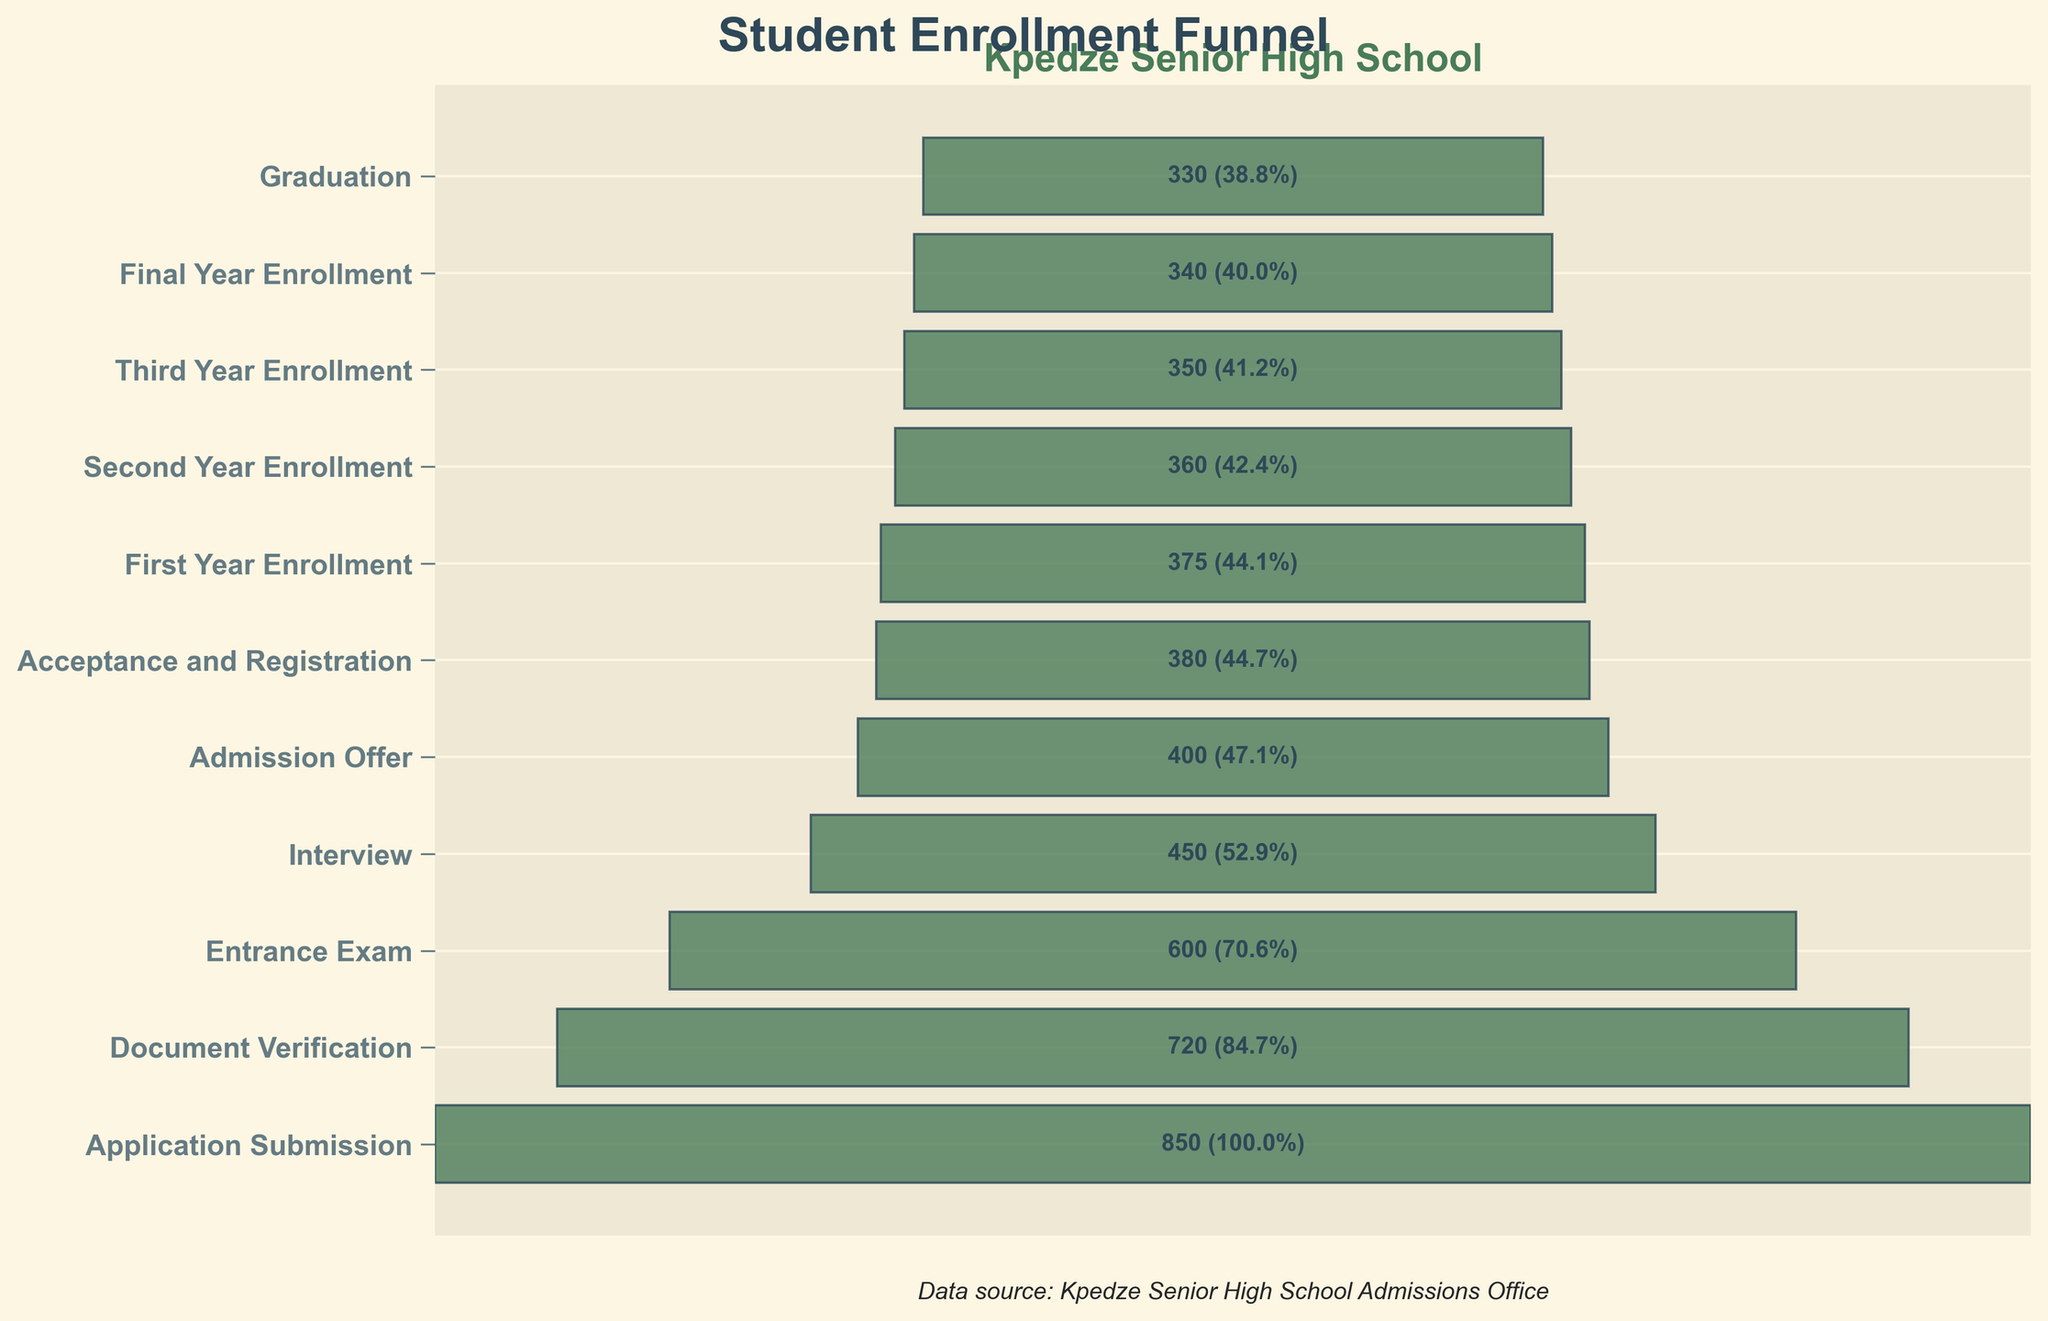What's the highest stage of student enrollment at Kpedze Senior High School? The highest stage in the funnel chart is the first stage at the top, which is 'Application Submission' with a total of 850 students.
Answer: Application Submission What is the title of the figure? The title of the figure is prominently displayed at the top of the chart, with a larger font size, often indicating the subject of the figure. In this chart, the title is 'Student Enrollment Funnel'.
Answer: Student Enrollment Funnel How many students accepted the admission offer and completed registration? To find the number of students at the 'Acceptance and Registration' stage, locate the corresponding stage in the funnel chart and refer to the indicated number of students.
Answer: 380 Which stages have fewer than 500 students? To determine which stages have fewer than 500 students, review the number of students next to each stage in the funnel chart. Any stage with a number below 500 meets this criterion. The stages 'Interview', 'Admission Offer', 'Acceptance and Registration', 'First Year Enrollment', 'Second Year Enrollment', 'Third Year Enrollment', 'Final Year Enrollment', and 'Graduation' all have fewer than 500 students.
Answer: Interview, Admission Offer, Acceptance and Registration, First Year Enrollment, Second Year Enrollment, Third Year Enrollment, Final Year Enrollment, Graduation How many students did not graduate after enrolling in the final year? To find this, subtract the number of students in the 'Graduation' stage from the number in the 'Final Year Enrollment' stage. In this case, it is 340 - 330.
Answer: 10 students How much does the student count drop from the 'Entrance Exam' stage to the 'Interview' stage? To find the drop in the number of students, subtract the number of students in the 'Interview' stage from the number in the 'Entrance Exam' stage. This is 600 - 450.
Answer: 150 students What's the percentage of students who go from 'Interview' to 'Admission Offer'? To find this, divide the number of students in the 'Admission Offer' stage by the number in the 'Interview' stage and multiply by 100. This is (400 / 450) * 100%.
Answer: 88.89% Which stage has the lowest count of students? Identify the stage with the smallest number of students from the funnel chart. The stage 'Graduation' has the lowest figure.
Answer: Graduation Compare the number of students between 'First Year Enrollment' and 'Second Year Enrollment'. Review the student counts for 'First Year Enrollment' and 'Second Year Enrollment' from the chart, then compare the two numbers. 'First Year Enrollment' has 375 students, and 'Second Year Enrollment' has 360.
Answer: First Year Enrollment has more students What is the overall trend seen in the student numbers from 'Application Submission' to 'Graduation'? By reviewing the student numbers progressively from 'Application Submission' at the top down to 'Graduation,' one notices the numbers generally decrease at each subsequent stage, indicating an attrition trend.
Answer: Decreasing trend 